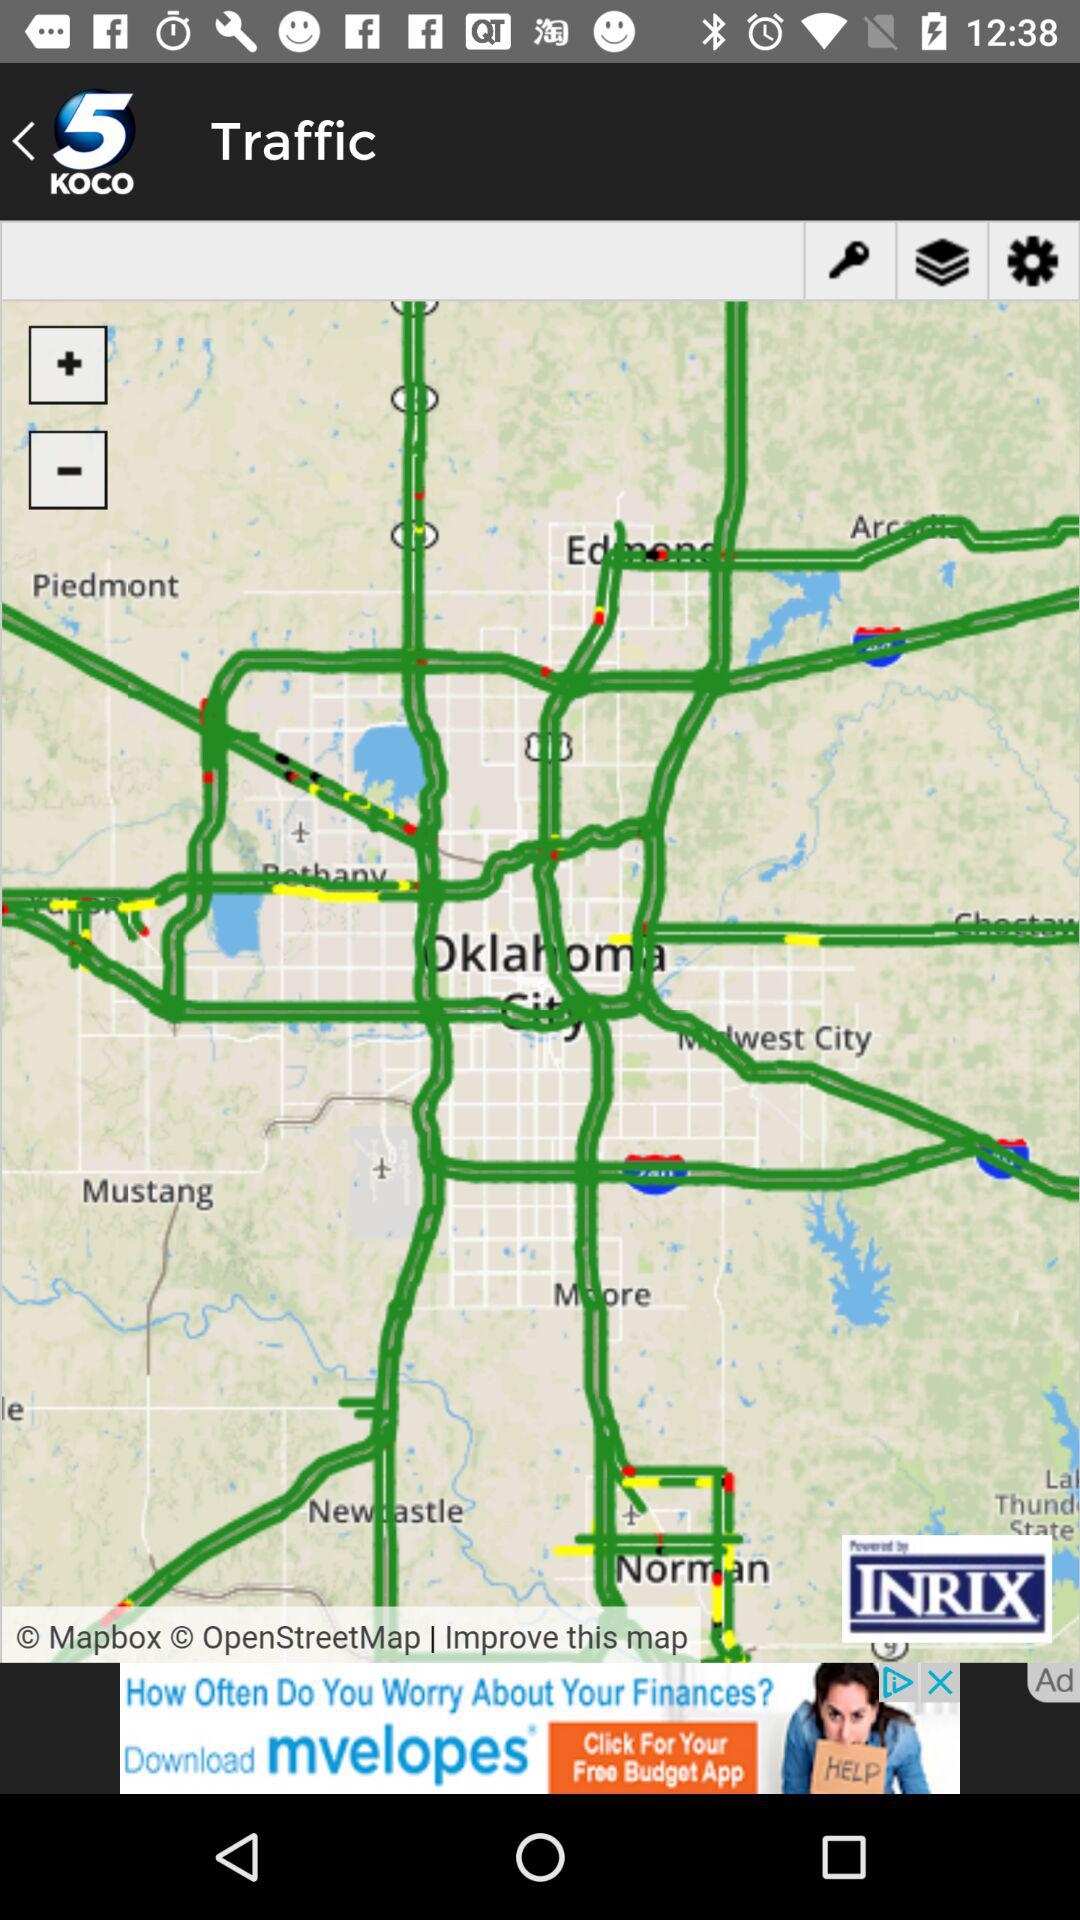What is the name of the application? The name of the application is "KOCO5". 